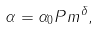Convert formula to latex. <formula><loc_0><loc_0><loc_500><loc_500>\alpha = \alpha _ { 0 } P m ^ { \delta } ,</formula> 